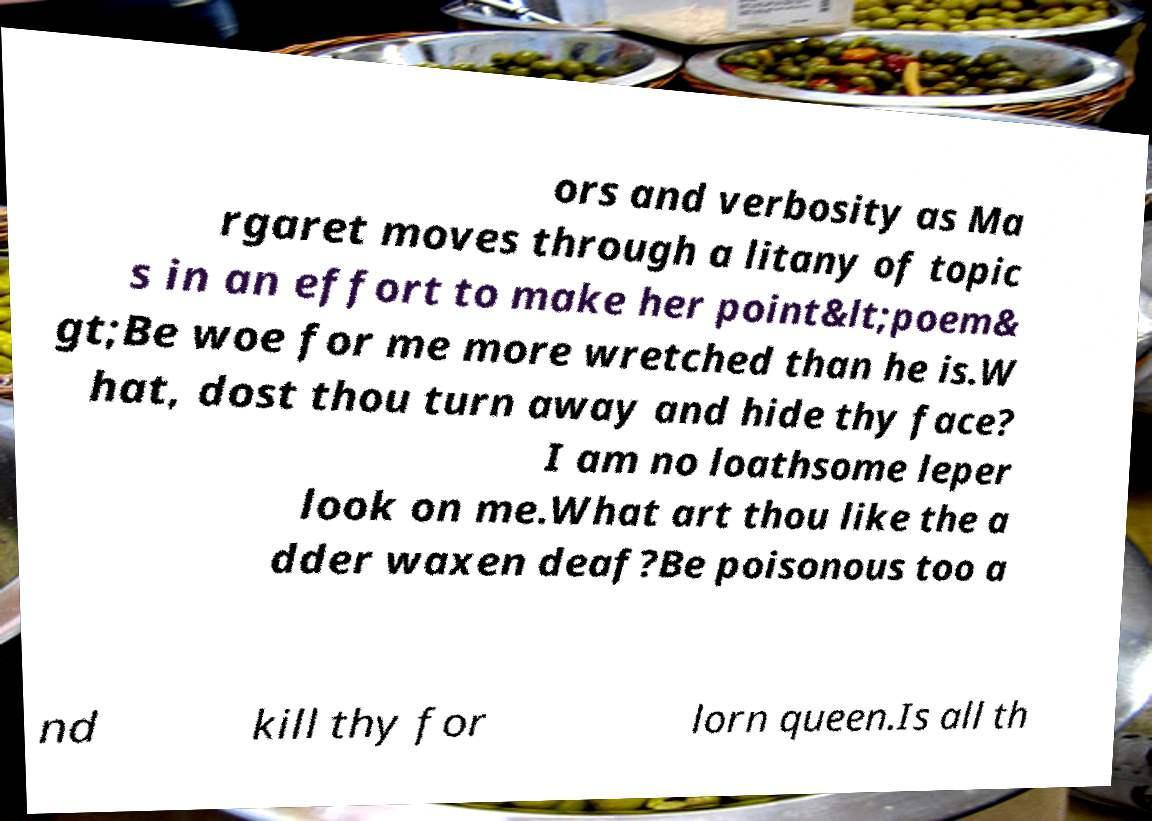I need the written content from this picture converted into text. Can you do that? ors and verbosity as Ma rgaret moves through a litany of topic s in an effort to make her point&lt;poem& gt;Be woe for me more wretched than he is.W hat, dost thou turn away and hide thy face? I am no loathsome leper look on me.What art thou like the a dder waxen deaf?Be poisonous too a nd kill thy for lorn queen.Is all th 